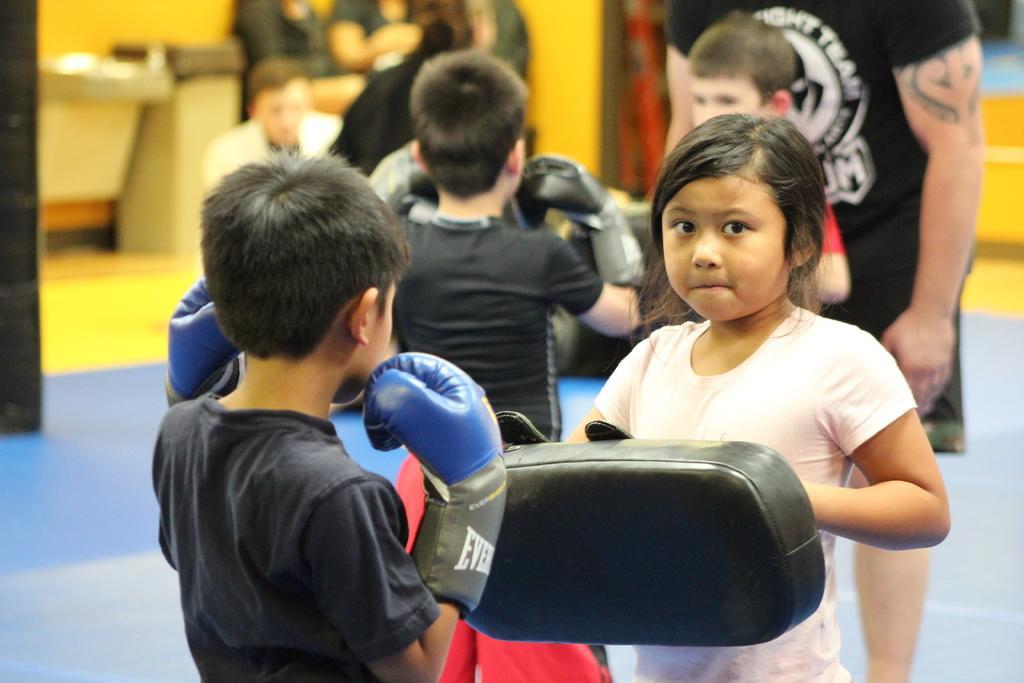Please provide a concise description of this image. In the foreground we can see a girl wearing white color dress, holding some object and standing and we can see the group of children wearing t-shirts, gloves and standing. In the background we can see the group of persons and many other objects. 